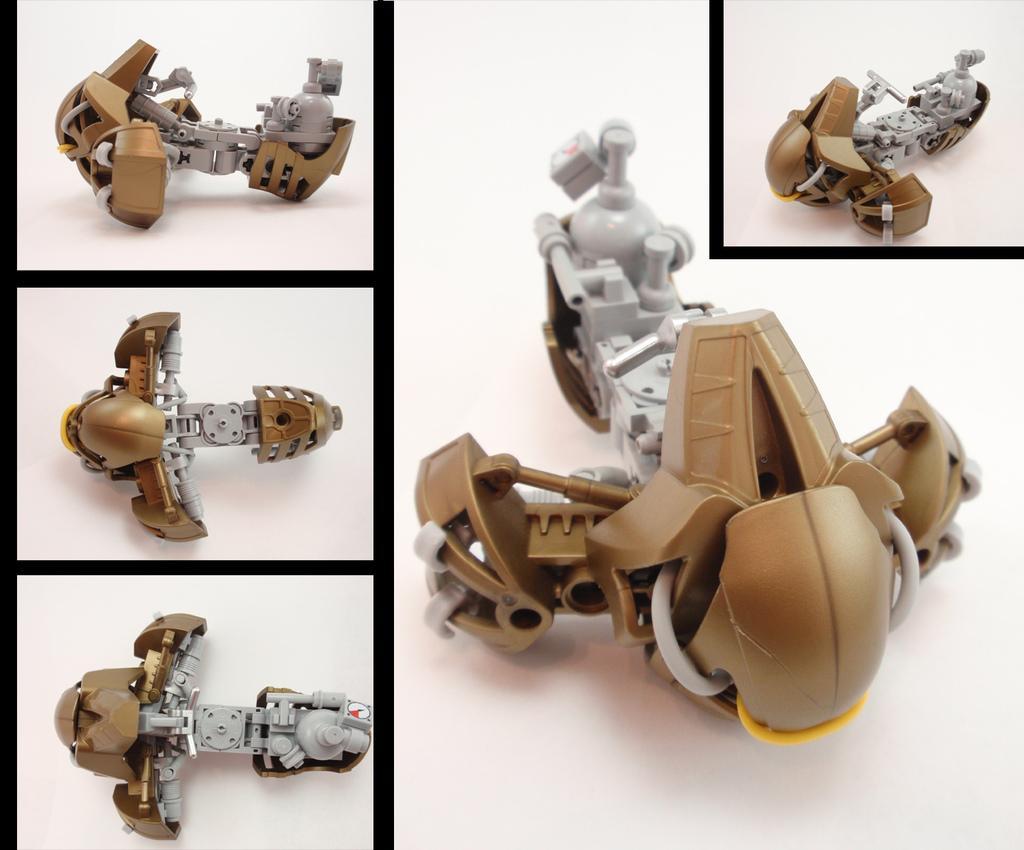Can you describe this image briefly? This is a collage picture. Here we can see toys. 